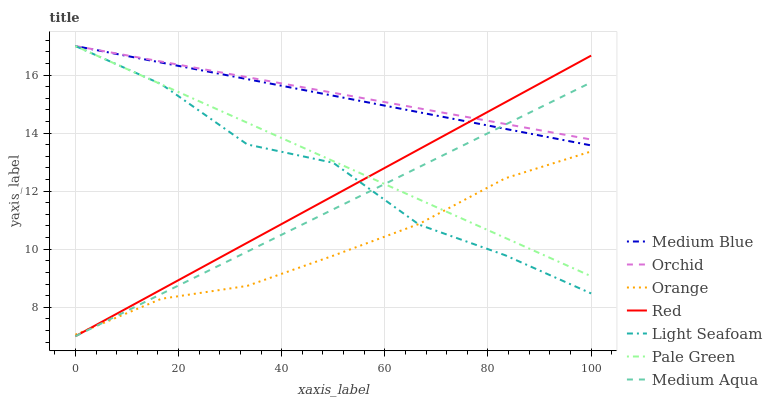Does Orange have the minimum area under the curve?
Answer yes or no. Yes. Does Orchid have the maximum area under the curve?
Answer yes or no. Yes. Does Pale Green have the minimum area under the curve?
Answer yes or no. No. Does Pale Green have the maximum area under the curve?
Answer yes or no. No. Is Medium Blue the smoothest?
Answer yes or no. Yes. Is Light Seafoam the roughest?
Answer yes or no. Yes. Is Pale Green the smoothest?
Answer yes or no. No. Is Pale Green the roughest?
Answer yes or no. No. Does Medium Aqua have the lowest value?
Answer yes or no. Yes. Does Pale Green have the lowest value?
Answer yes or no. No. Does Orchid have the highest value?
Answer yes or no. Yes. Does Medium Aqua have the highest value?
Answer yes or no. No. Is Orange less than Medium Blue?
Answer yes or no. Yes. Is Orchid greater than Orange?
Answer yes or no. Yes. Does Orchid intersect Pale Green?
Answer yes or no. Yes. Is Orchid less than Pale Green?
Answer yes or no. No. Is Orchid greater than Pale Green?
Answer yes or no. No. Does Orange intersect Medium Blue?
Answer yes or no. No. 